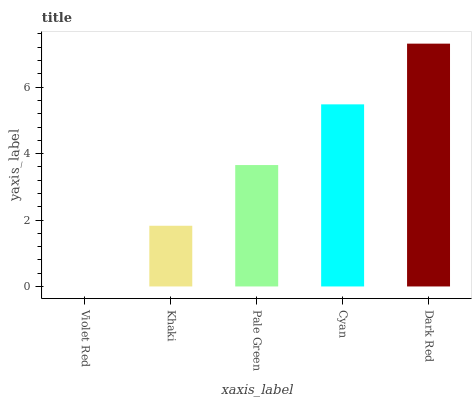Is Violet Red the minimum?
Answer yes or no. Yes. Is Dark Red the maximum?
Answer yes or no. Yes. Is Khaki the minimum?
Answer yes or no. No. Is Khaki the maximum?
Answer yes or no. No. Is Khaki greater than Violet Red?
Answer yes or no. Yes. Is Violet Red less than Khaki?
Answer yes or no. Yes. Is Violet Red greater than Khaki?
Answer yes or no. No. Is Khaki less than Violet Red?
Answer yes or no. No. Is Pale Green the high median?
Answer yes or no. Yes. Is Pale Green the low median?
Answer yes or no. Yes. Is Khaki the high median?
Answer yes or no. No. Is Cyan the low median?
Answer yes or no. No. 